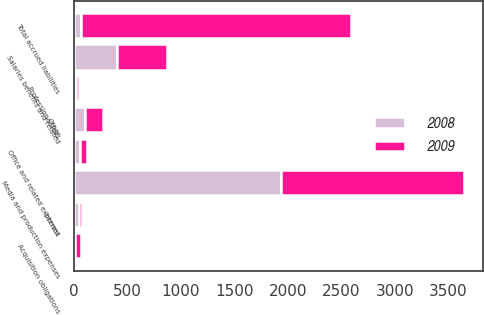<chart> <loc_0><loc_0><loc_500><loc_500><stacked_bar_chart><ecel><fcel>Media and production expenses<fcel>Salaries benefits and related<fcel>Office and related expenses<fcel>Professional fees<fcel>Interest<fcel>Acquisition obligations<fcel>Other<fcel>Total accrued liabilities<nl><fcel>2008<fcel>1936.1<fcel>405.7<fcel>59.5<fcel>20.4<fcel>46.6<fcel>16.6<fcel>108.2<fcel>69.6<nl><fcel>2009<fcel>1708.3<fcel>466.5<fcel>69.6<fcel>24.7<fcel>30.6<fcel>53.9<fcel>168<fcel>2521.6<nl></chart> 